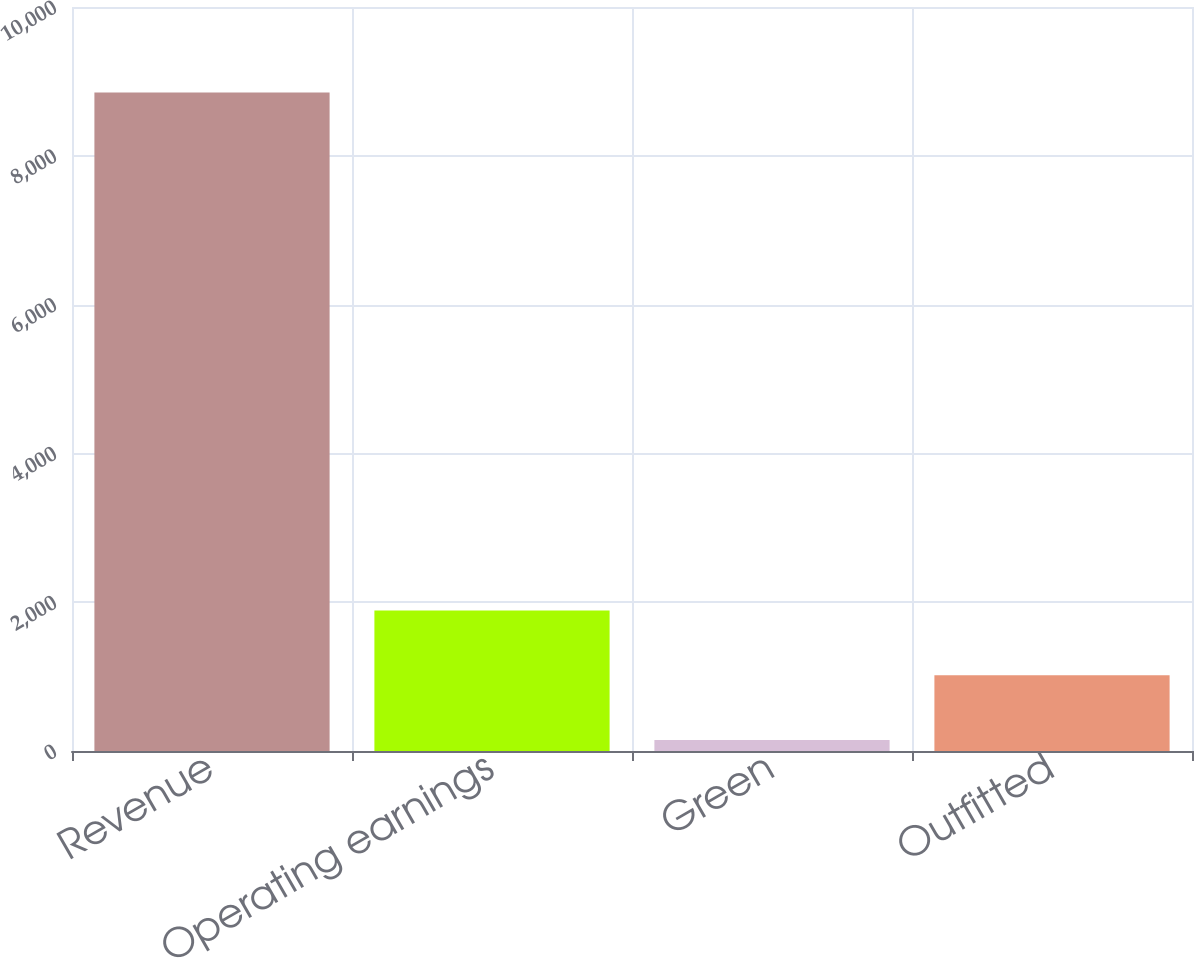Convert chart to OTSL. <chart><loc_0><loc_0><loc_500><loc_500><bar_chart><fcel>Revenue<fcel>Operating earnings<fcel>Green<fcel>Outfitted<nl><fcel>8851<fcel>1887.8<fcel>147<fcel>1017.4<nl></chart> 